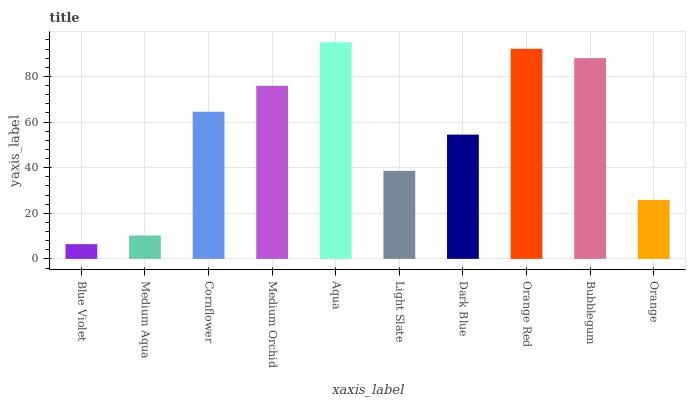Is Blue Violet the minimum?
Answer yes or no. Yes. Is Aqua the maximum?
Answer yes or no. Yes. Is Medium Aqua the minimum?
Answer yes or no. No. Is Medium Aqua the maximum?
Answer yes or no. No. Is Medium Aqua greater than Blue Violet?
Answer yes or no. Yes. Is Blue Violet less than Medium Aqua?
Answer yes or no. Yes. Is Blue Violet greater than Medium Aqua?
Answer yes or no. No. Is Medium Aqua less than Blue Violet?
Answer yes or no. No. Is Cornflower the high median?
Answer yes or no. Yes. Is Dark Blue the low median?
Answer yes or no. Yes. Is Orange Red the high median?
Answer yes or no. No. Is Medium Aqua the low median?
Answer yes or no. No. 